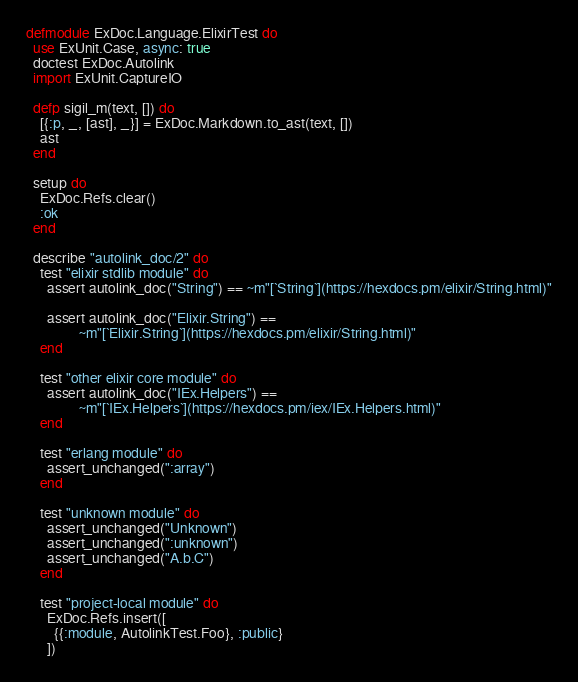Convert code to text. <code><loc_0><loc_0><loc_500><loc_500><_Elixir_>defmodule ExDoc.Language.ElixirTest do
  use ExUnit.Case, async: true
  doctest ExDoc.Autolink
  import ExUnit.CaptureIO

  defp sigil_m(text, []) do
    [{:p, _, [ast], _}] = ExDoc.Markdown.to_ast(text, [])
    ast
  end

  setup do
    ExDoc.Refs.clear()
    :ok
  end

  describe "autolink_doc/2" do
    test "elixir stdlib module" do
      assert autolink_doc("String") == ~m"[`String`](https://hexdocs.pm/elixir/String.html)"

      assert autolink_doc("Elixir.String") ==
               ~m"[`Elixir.String`](https://hexdocs.pm/elixir/String.html)"
    end

    test "other elixir core module" do
      assert autolink_doc("IEx.Helpers") ==
               ~m"[`IEx.Helpers`](https://hexdocs.pm/iex/IEx.Helpers.html)"
    end

    test "erlang module" do
      assert_unchanged(":array")
    end

    test "unknown module" do
      assert_unchanged("Unknown")
      assert_unchanged(":unknown")
      assert_unchanged("A.b.C")
    end

    test "project-local module" do
      ExDoc.Refs.insert([
        {{:module, AutolinkTest.Foo}, :public}
      ])
</code> 